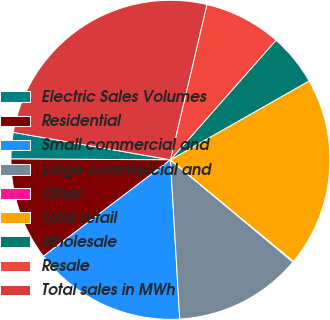Convert chart to OTSL. <chart><loc_0><loc_0><loc_500><loc_500><pie_chart><fcel>Electric Sales Volumes<fcel>Residential<fcel>Small commercial and<fcel>Large commercial and<fcel>Other<fcel>Total retail<fcel>Wholesale<fcel>Resale<fcel>Total sales in MWh<nl><fcel>2.67%<fcel>10.42%<fcel>15.59%<fcel>13.0%<fcel>0.09%<fcel>19.21%<fcel>5.26%<fcel>7.84%<fcel>25.92%<nl></chart> 